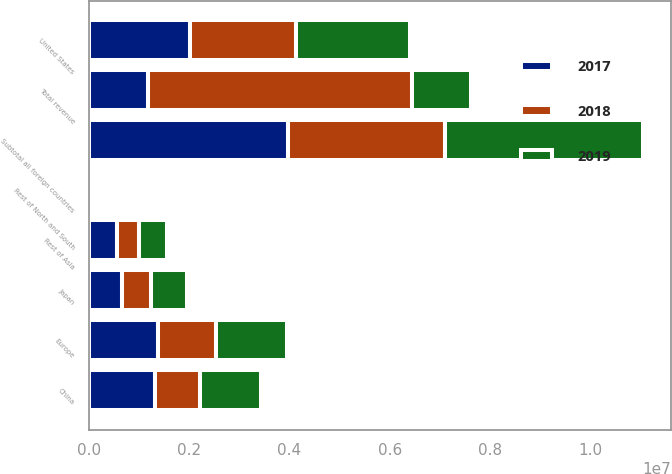Convert chart. <chart><loc_0><loc_0><loc_500><loc_500><stacked_bar_chart><ecel><fcel>United States<fcel>Rest of North and South<fcel>Europe<fcel>Japan<fcel>China<fcel>Rest of Asia<fcel>Subtotal all foreign countries<fcel>Total revenue<nl><fcel>2017<fcel>2.02089e+06<fcel>55059<fcel>1.37467e+06<fcel>657632<fcel>1.31628e+06<fcel>566540<fcel>3.97018e+06<fcel>1.19034e+06<nl><fcel>2019<fcel>2.27708e+06<fcel>46276<fcel>1.40569e+06<fcel>714846<fcel>1.21595e+06<fcel>564848<fcel>3.9476e+06<fcel>1.19034e+06<nl><fcel>2018<fcel>2.11054e+06<fcel>48620<fcel>1.16472e+06<fcel>586521<fcel>898645<fcel>437298<fcel>3.13581e+06<fcel>5.24635e+06<nl></chart> 